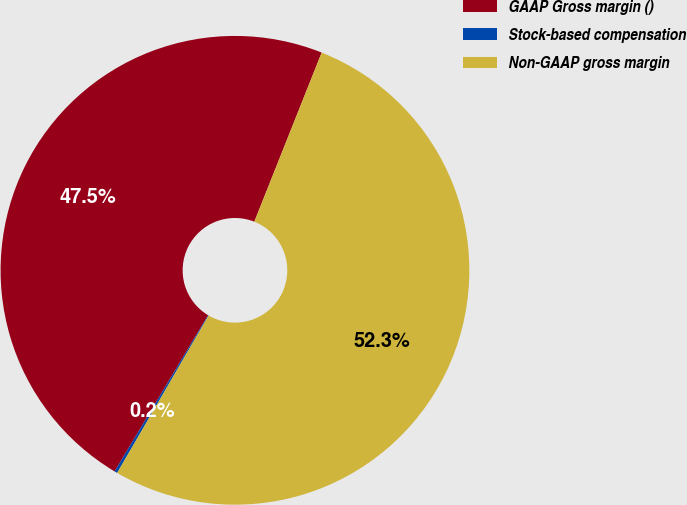Convert chart to OTSL. <chart><loc_0><loc_0><loc_500><loc_500><pie_chart><fcel>GAAP Gross margin ()<fcel>Stock-based compensation<fcel>Non-GAAP gross margin<nl><fcel>47.45%<fcel>0.2%<fcel>52.35%<nl></chart> 